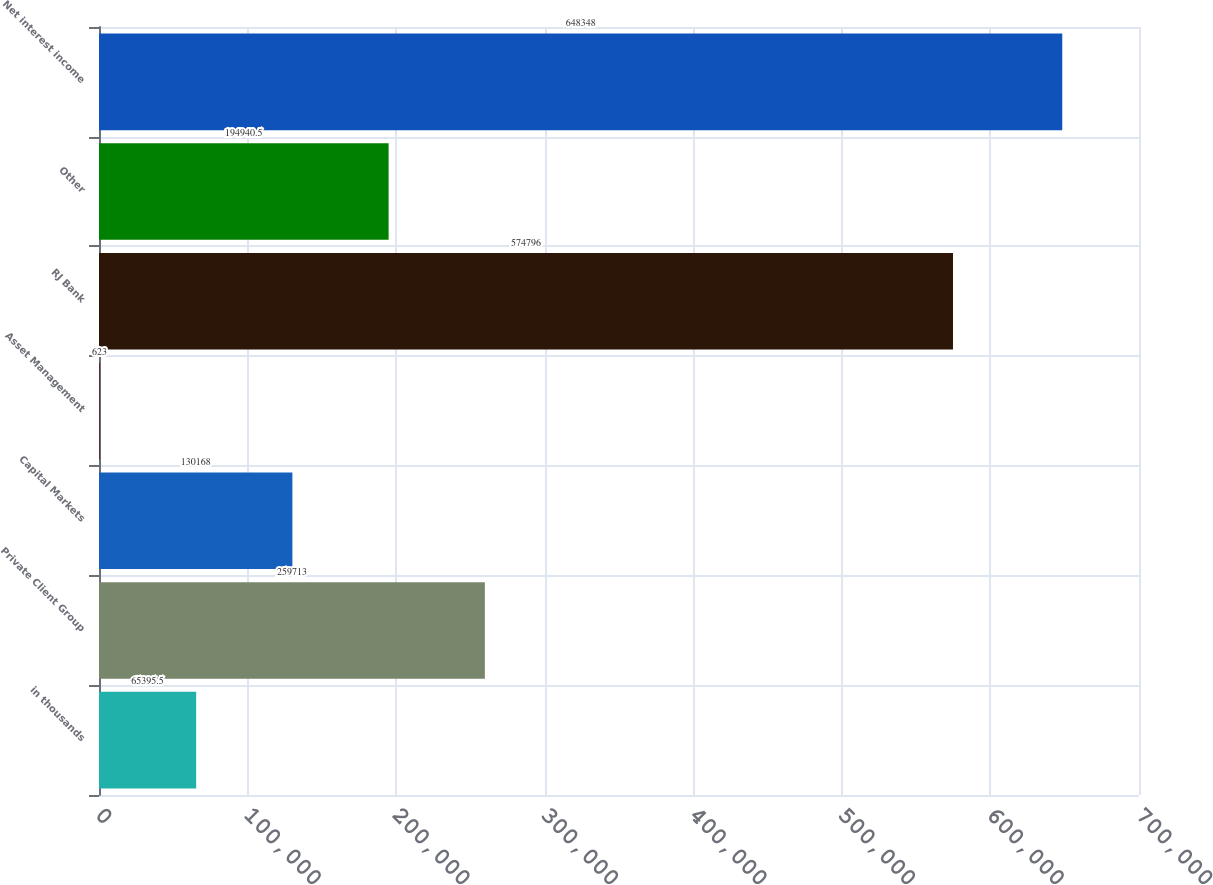Convert chart. <chart><loc_0><loc_0><loc_500><loc_500><bar_chart><fcel>in thousands<fcel>Private Client Group<fcel>Capital Markets<fcel>Asset Management<fcel>RJ Bank<fcel>Other<fcel>Net interest income<nl><fcel>65395.5<fcel>259713<fcel>130168<fcel>623<fcel>574796<fcel>194940<fcel>648348<nl></chart> 